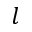<formula> <loc_0><loc_0><loc_500><loc_500>l</formula> 